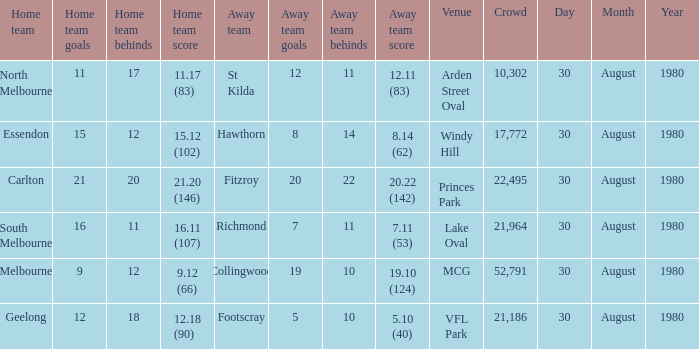What is the home team score at lake oval? 16.11 (107). 